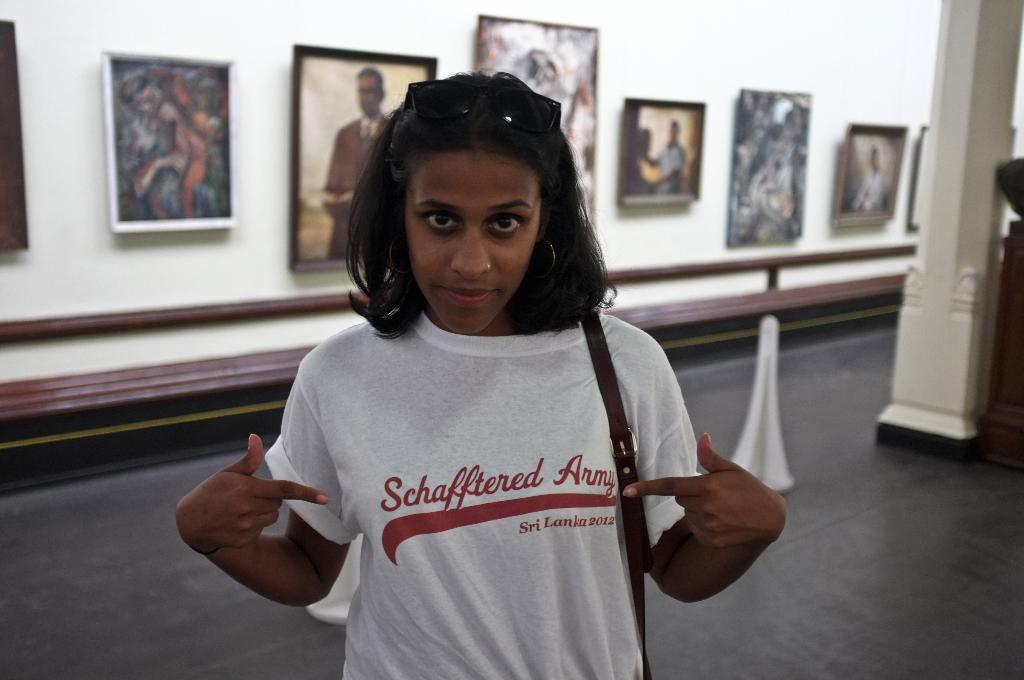What is the main subject in the image? There is a lady standing in the image. What can be seen on the right side of the image? There is a pillar on the right side of the image. What is visible in the background of the image? There is a wall in the background of the image. What is placed on the wall in the background? Photo frames are placed on the wall in the background. What type of wine is being served in the image? There is no wine present in the image; it features a lady standing near a pillar with a wall and photo frames in the background. 